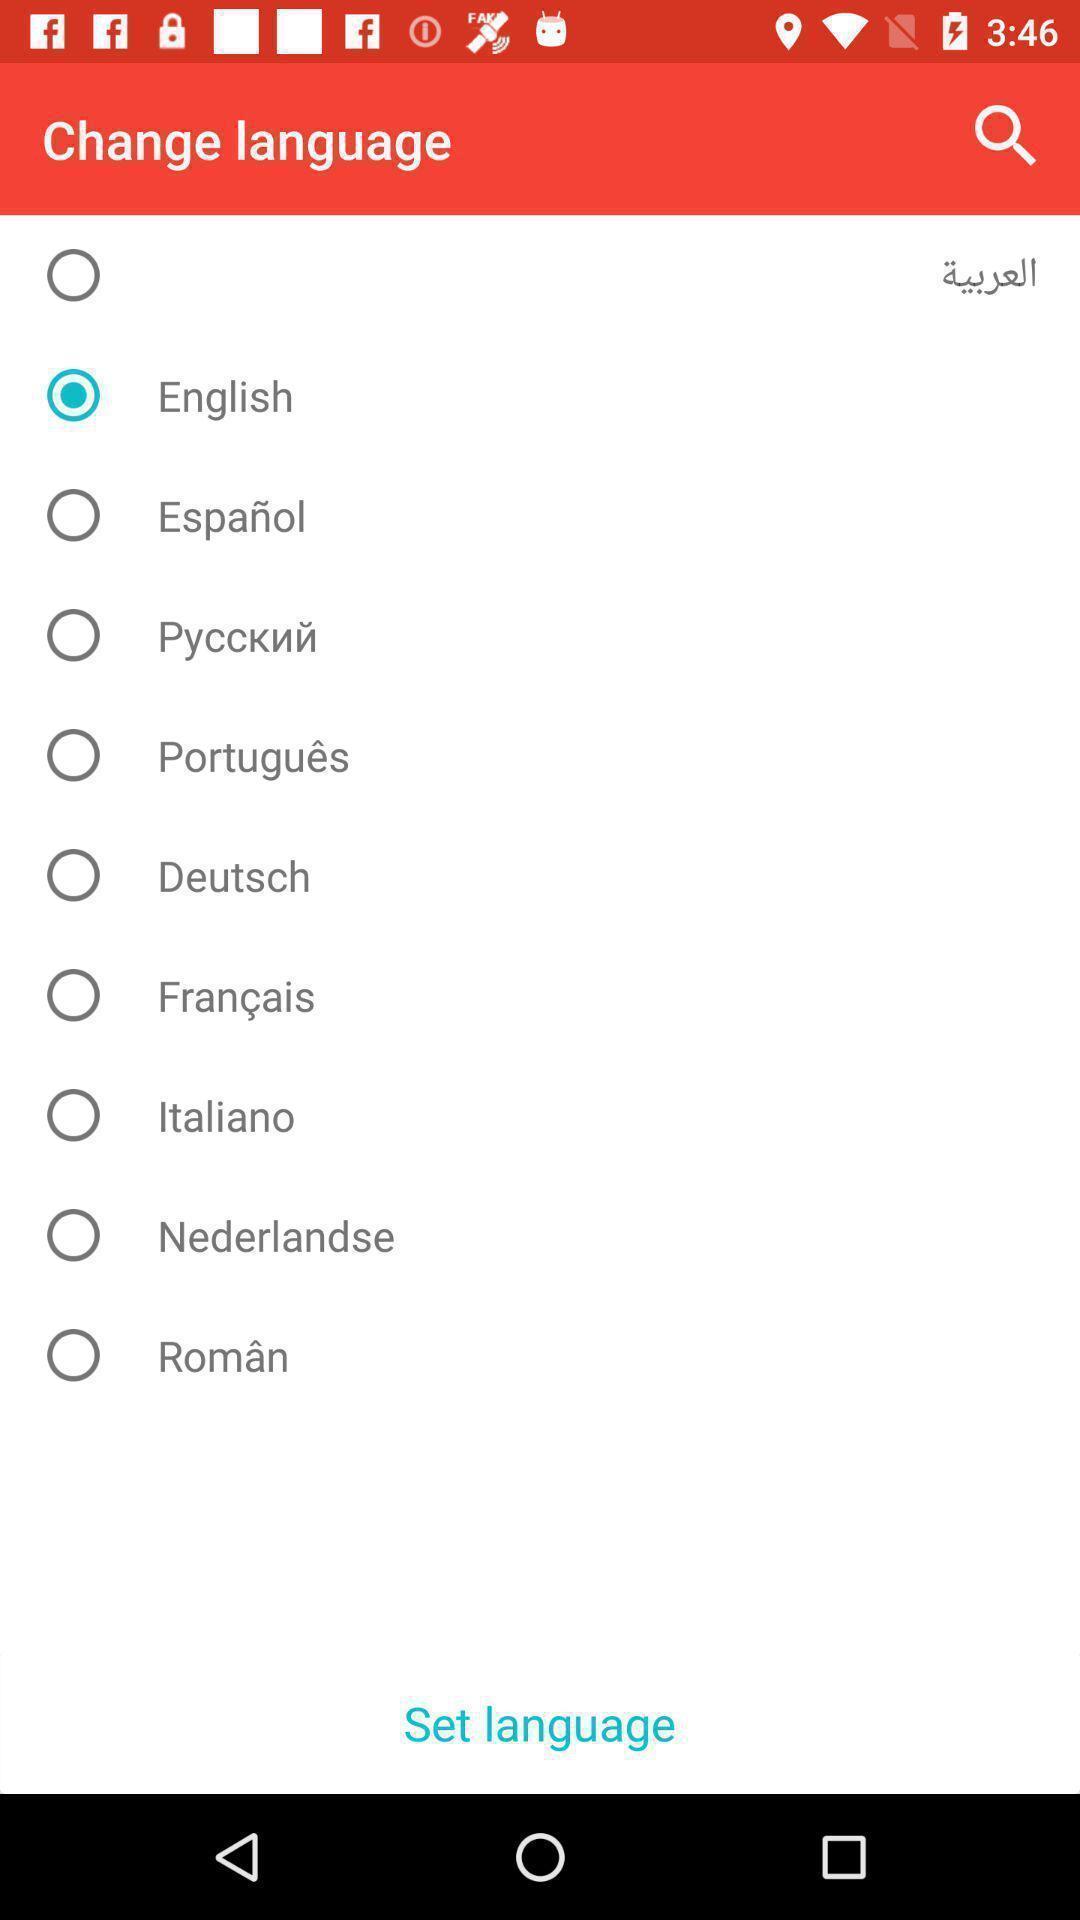What can you discern from this picture? Selection of language page in a recipe book app. 